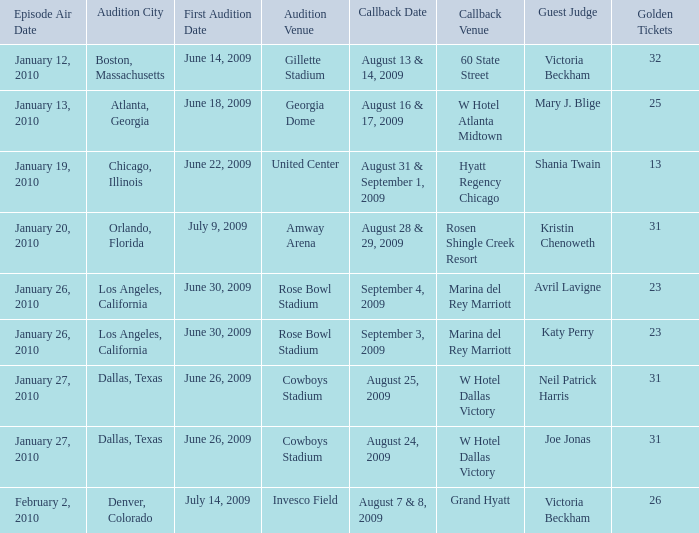Name the guest judge for first audition date being july 9, 2009 1.0. 